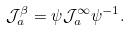Convert formula to latex. <formula><loc_0><loc_0><loc_500><loc_500>\mathcal { J } _ { a } ^ { \beta } = \psi \mathcal { J } _ { a } ^ { \infty } \psi ^ { - 1 } .</formula> 